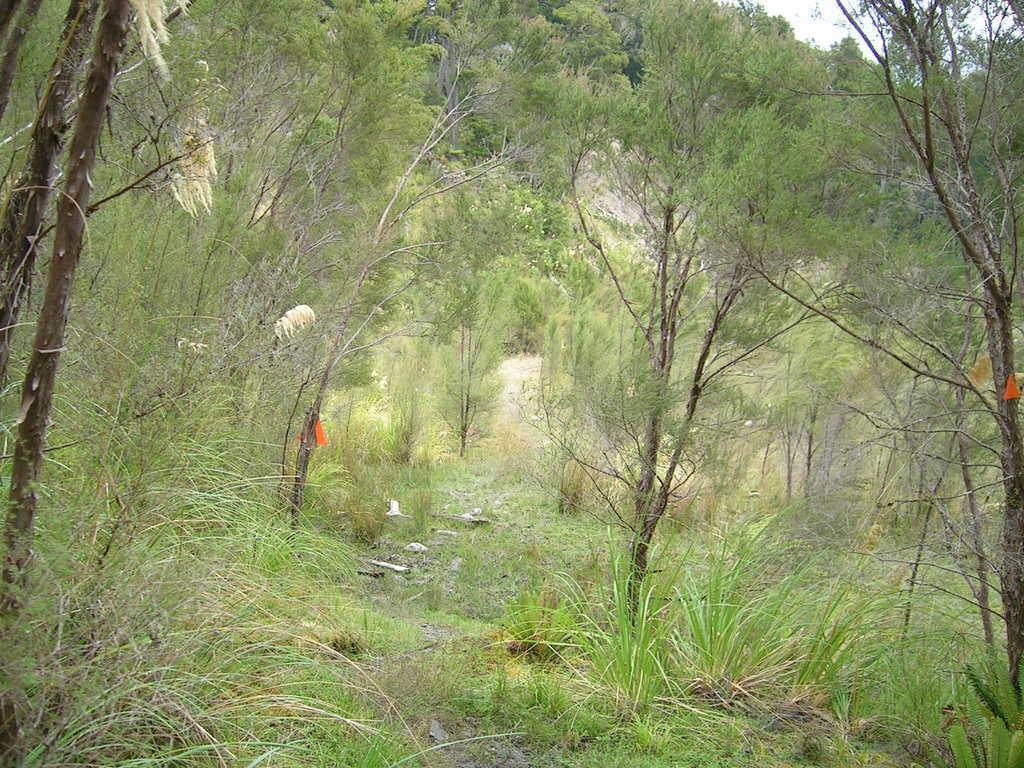Can you describe this image briefly? In the center of the image there are trees. At the bottom there is grass. In the background there is sky. 